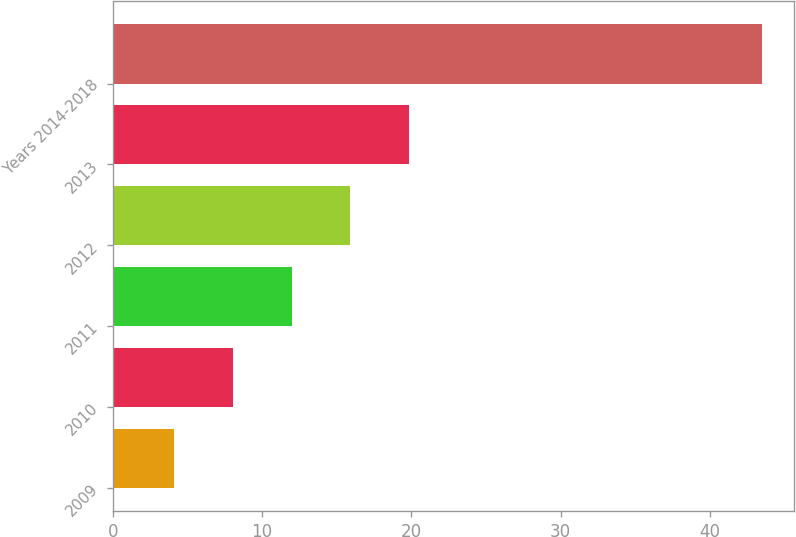Convert chart to OTSL. <chart><loc_0><loc_0><loc_500><loc_500><bar_chart><fcel>2009<fcel>2010<fcel>2011<fcel>2012<fcel>2013<fcel>Years 2014-2018<nl><fcel>4.1<fcel>8.04<fcel>11.98<fcel>15.92<fcel>19.86<fcel>43.5<nl></chart> 